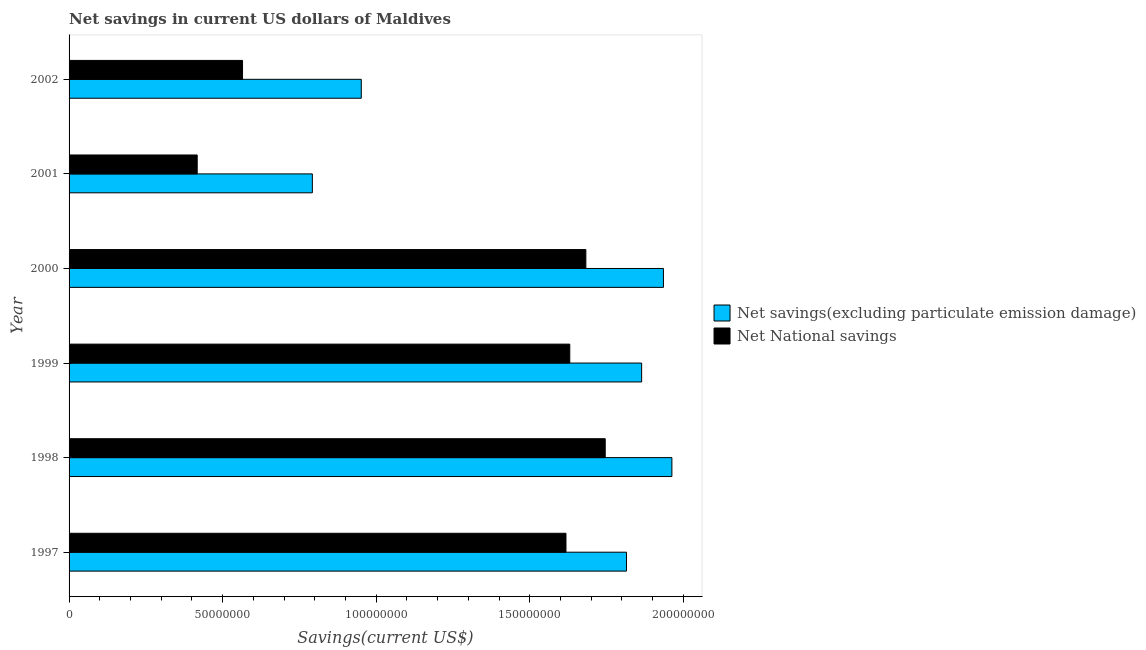Are the number of bars on each tick of the Y-axis equal?
Give a very brief answer. Yes. How many bars are there on the 2nd tick from the top?
Keep it short and to the point. 2. How many bars are there on the 6th tick from the bottom?
Make the answer very short. 2. What is the label of the 5th group of bars from the top?
Ensure brevity in your answer.  1998. In how many cases, is the number of bars for a given year not equal to the number of legend labels?
Provide a succinct answer. 0. What is the net savings(excluding particulate emission damage) in 2002?
Your response must be concise. 9.51e+07. Across all years, what is the maximum net national savings?
Offer a terse response. 1.75e+08. Across all years, what is the minimum net savings(excluding particulate emission damage)?
Your answer should be very brief. 7.92e+07. In which year was the net national savings minimum?
Give a very brief answer. 2001. What is the total net national savings in the graph?
Your answer should be very brief. 7.66e+08. What is the difference between the net national savings in 1997 and that in 1998?
Offer a very short reply. -1.28e+07. What is the difference between the net savings(excluding particulate emission damage) in 1998 and the net national savings in 2001?
Offer a terse response. 1.55e+08. What is the average net savings(excluding particulate emission damage) per year?
Keep it short and to the point. 1.55e+08. In the year 2000, what is the difference between the net savings(excluding particulate emission damage) and net national savings?
Give a very brief answer. 2.53e+07. In how many years, is the net national savings greater than 60000000 US$?
Provide a short and direct response. 4. What is the ratio of the net savings(excluding particulate emission damage) in 1997 to that in 2001?
Keep it short and to the point. 2.29. What is the difference between the highest and the second highest net savings(excluding particulate emission damage)?
Offer a very short reply. 2.75e+06. What is the difference between the highest and the lowest net savings(excluding particulate emission damage)?
Your answer should be compact. 1.17e+08. Is the sum of the net savings(excluding particulate emission damage) in 2001 and 2002 greater than the maximum net national savings across all years?
Provide a succinct answer. No. What does the 1st bar from the top in 1999 represents?
Provide a succinct answer. Net National savings. What does the 1st bar from the bottom in 2000 represents?
Your answer should be very brief. Net savings(excluding particulate emission damage). Are all the bars in the graph horizontal?
Your answer should be very brief. Yes. What is the difference between two consecutive major ticks on the X-axis?
Provide a short and direct response. 5.00e+07. Are the values on the major ticks of X-axis written in scientific E-notation?
Ensure brevity in your answer.  No. How are the legend labels stacked?
Offer a terse response. Vertical. What is the title of the graph?
Make the answer very short. Net savings in current US dollars of Maldives. Does "Borrowers" appear as one of the legend labels in the graph?
Keep it short and to the point. No. What is the label or title of the X-axis?
Make the answer very short. Savings(current US$). What is the Savings(current US$) in Net savings(excluding particulate emission damage) in 1997?
Ensure brevity in your answer.  1.81e+08. What is the Savings(current US$) in Net National savings in 1997?
Provide a succinct answer. 1.62e+08. What is the Savings(current US$) of Net savings(excluding particulate emission damage) in 1998?
Give a very brief answer. 1.96e+08. What is the Savings(current US$) in Net National savings in 1998?
Your response must be concise. 1.75e+08. What is the Savings(current US$) in Net savings(excluding particulate emission damage) in 1999?
Ensure brevity in your answer.  1.86e+08. What is the Savings(current US$) of Net National savings in 1999?
Provide a short and direct response. 1.63e+08. What is the Savings(current US$) in Net savings(excluding particulate emission damage) in 2000?
Your answer should be very brief. 1.94e+08. What is the Savings(current US$) of Net National savings in 2000?
Keep it short and to the point. 1.68e+08. What is the Savings(current US$) of Net savings(excluding particulate emission damage) in 2001?
Provide a short and direct response. 7.92e+07. What is the Savings(current US$) in Net National savings in 2001?
Give a very brief answer. 4.17e+07. What is the Savings(current US$) in Net savings(excluding particulate emission damage) in 2002?
Your response must be concise. 9.51e+07. What is the Savings(current US$) in Net National savings in 2002?
Give a very brief answer. 5.65e+07. Across all years, what is the maximum Savings(current US$) of Net savings(excluding particulate emission damage)?
Offer a very short reply. 1.96e+08. Across all years, what is the maximum Savings(current US$) of Net National savings?
Offer a very short reply. 1.75e+08. Across all years, what is the minimum Savings(current US$) of Net savings(excluding particulate emission damage)?
Your answer should be compact. 7.92e+07. Across all years, what is the minimum Savings(current US$) of Net National savings?
Offer a terse response. 4.17e+07. What is the total Savings(current US$) of Net savings(excluding particulate emission damage) in the graph?
Give a very brief answer. 9.32e+08. What is the total Savings(current US$) in Net National savings in the graph?
Keep it short and to the point. 7.66e+08. What is the difference between the Savings(current US$) of Net savings(excluding particulate emission damage) in 1997 and that in 1998?
Make the answer very short. -1.48e+07. What is the difference between the Savings(current US$) in Net National savings in 1997 and that in 1998?
Ensure brevity in your answer.  -1.28e+07. What is the difference between the Savings(current US$) in Net savings(excluding particulate emission damage) in 1997 and that in 1999?
Your answer should be very brief. -4.94e+06. What is the difference between the Savings(current US$) in Net National savings in 1997 and that in 1999?
Offer a terse response. -1.24e+06. What is the difference between the Savings(current US$) of Net savings(excluding particulate emission damage) in 1997 and that in 2000?
Offer a terse response. -1.20e+07. What is the difference between the Savings(current US$) in Net National savings in 1997 and that in 2000?
Provide a succinct answer. -6.48e+06. What is the difference between the Savings(current US$) of Net savings(excluding particulate emission damage) in 1997 and that in 2001?
Ensure brevity in your answer.  1.02e+08. What is the difference between the Savings(current US$) of Net National savings in 1997 and that in 2001?
Offer a very short reply. 1.20e+08. What is the difference between the Savings(current US$) in Net savings(excluding particulate emission damage) in 1997 and that in 2002?
Ensure brevity in your answer.  8.63e+07. What is the difference between the Savings(current US$) of Net National savings in 1997 and that in 2002?
Give a very brief answer. 1.05e+08. What is the difference between the Savings(current US$) of Net savings(excluding particulate emission damage) in 1998 and that in 1999?
Ensure brevity in your answer.  9.85e+06. What is the difference between the Savings(current US$) of Net National savings in 1998 and that in 1999?
Ensure brevity in your answer.  1.15e+07. What is the difference between the Savings(current US$) of Net savings(excluding particulate emission damage) in 1998 and that in 2000?
Give a very brief answer. 2.75e+06. What is the difference between the Savings(current US$) in Net National savings in 1998 and that in 2000?
Provide a short and direct response. 6.30e+06. What is the difference between the Savings(current US$) in Net savings(excluding particulate emission damage) in 1998 and that in 2001?
Offer a very short reply. 1.17e+08. What is the difference between the Savings(current US$) of Net National savings in 1998 and that in 2001?
Ensure brevity in your answer.  1.33e+08. What is the difference between the Savings(current US$) in Net savings(excluding particulate emission damage) in 1998 and that in 2002?
Provide a short and direct response. 1.01e+08. What is the difference between the Savings(current US$) of Net National savings in 1998 and that in 2002?
Give a very brief answer. 1.18e+08. What is the difference between the Savings(current US$) in Net savings(excluding particulate emission damage) in 1999 and that in 2000?
Make the answer very short. -7.10e+06. What is the difference between the Savings(current US$) in Net National savings in 1999 and that in 2000?
Provide a short and direct response. -5.24e+06. What is the difference between the Savings(current US$) of Net savings(excluding particulate emission damage) in 1999 and that in 2001?
Offer a very short reply. 1.07e+08. What is the difference between the Savings(current US$) of Net National savings in 1999 and that in 2001?
Your answer should be very brief. 1.21e+08. What is the difference between the Savings(current US$) in Net savings(excluding particulate emission damage) in 1999 and that in 2002?
Ensure brevity in your answer.  9.13e+07. What is the difference between the Savings(current US$) of Net National savings in 1999 and that in 2002?
Your response must be concise. 1.07e+08. What is the difference between the Savings(current US$) in Net savings(excluding particulate emission damage) in 2000 and that in 2001?
Offer a terse response. 1.14e+08. What is the difference between the Savings(current US$) of Net National savings in 2000 and that in 2001?
Make the answer very short. 1.27e+08. What is the difference between the Savings(current US$) in Net savings(excluding particulate emission damage) in 2000 and that in 2002?
Offer a terse response. 9.84e+07. What is the difference between the Savings(current US$) of Net National savings in 2000 and that in 2002?
Your answer should be compact. 1.12e+08. What is the difference between the Savings(current US$) in Net savings(excluding particulate emission damage) in 2001 and that in 2002?
Keep it short and to the point. -1.59e+07. What is the difference between the Savings(current US$) in Net National savings in 2001 and that in 2002?
Provide a short and direct response. -1.48e+07. What is the difference between the Savings(current US$) in Net savings(excluding particulate emission damage) in 1997 and the Savings(current US$) in Net National savings in 1998?
Your answer should be compact. 6.92e+06. What is the difference between the Savings(current US$) in Net savings(excluding particulate emission damage) in 1997 and the Savings(current US$) in Net National savings in 1999?
Provide a short and direct response. 1.85e+07. What is the difference between the Savings(current US$) in Net savings(excluding particulate emission damage) in 1997 and the Savings(current US$) in Net National savings in 2000?
Give a very brief answer. 1.32e+07. What is the difference between the Savings(current US$) in Net savings(excluding particulate emission damage) in 1997 and the Savings(current US$) in Net National savings in 2001?
Your response must be concise. 1.40e+08. What is the difference between the Savings(current US$) of Net savings(excluding particulate emission damage) in 1997 and the Savings(current US$) of Net National savings in 2002?
Provide a short and direct response. 1.25e+08. What is the difference between the Savings(current US$) in Net savings(excluding particulate emission damage) in 1998 and the Savings(current US$) in Net National savings in 1999?
Provide a succinct answer. 3.32e+07. What is the difference between the Savings(current US$) of Net savings(excluding particulate emission damage) in 1998 and the Savings(current US$) of Net National savings in 2000?
Your response must be concise. 2.80e+07. What is the difference between the Savings(current US$) of Net savings(excluding particulate emission damage) in 1998 and the Savings(current US$) of Net National savings in 2001?
Offer a very short reply. 1.55e+08. What is the difference between the Savings(current US$) in Net savings(excluding particulate emission damage) in 1998 and the Savings(current US$) in Net National savings in 2002?
Ensure brevity in your answer.  1.40e+08. What is the difference between the Savings(current US$) in Net savings(excluding particulate emission damage) in 1999 and the Savings(current US$) in Net National savings in 2000?
Offer a very short reply. 1.82e+07. What is the difference between the Savings(current US$) of Net savings(excluding particulate emission damage) in 1999 and the Savings(current US$) of Net National savings in 2001?
Offer a terse response. 1.45e+08. What is the difference between the Savings(current US$) of Net savings(excluding particulate emission damage) in 1999 and the Savings(current US$) of Net National savings in 2002?
Provide a short and direct response. 1.30e+08. What is the difference between the Savings(current US$) of Net savings(excluding particulate emission damage) in 2000 and the Savings(current US$) of Net National savings in 2001?
Provide a short and direct response. 1.52e+08. What is the difference between the Savings(current US$) in Net savings(excluding particulate emission damage) in 2000 and the Savings(current US$) in Net National savings in 2002?
Your answer should be compact. 1.37e+08. What is the difference between the Savings(current US$) in Net savings(excluding particulate emission damage) in 2001 and the Savings(current US$) in Net National savings in 2002?
Make the answer very short. 2.27e+07. What is the average Savings(current US$) in Net savings(excluding particulate emission damage) per year?
Offer a terse response. 1.55e+08. What is the average Savings(current US$) in Net National savings per year?
Give a very brief answer. 1.28e+08. In the year 1997, what is the difference between the Savings(current US$) in Net savings(excluding particulate emission damage) and Savings(current US$) in Net National savings?
Make the answer very short. 1.97e+07. In the year 1998, what is the difference between the Savings(current US$) in Net savings(excluding particulate emission damage) and Savings(current US$) in Net National savings?
Your answer should be very brief. 2.17e+07. In the year 1999, what is the difference between the Savings(current US$) in Net savings(excluding particulate emission damage) and Savings(current US$) in Net National savings?
Offer a very short reply. 2.34e+07. In the year 2000, what is the difference between the Savings(current US$) of Net savings(excluding particulate emission damage) and Savings(current US$) of Net National savings?
Your answer should be very brief. 2.53e+07. In the year 2001, what is the difference between the Savings(current US$) in Net savings(excluding particulate emission damage) and Savings(current US$) in Net National savings?
Provide a short and direct response. 3.75e+07. In the year 2002, what is the difference between the Savings(current US$) of Net savings(excluding particulate emission damage) and Savings(current US$) of Net National savings?
Make the answer very short. 3.87e+07. What is the ratio of the Savings(current US$) in Net savings(excluding particulate emission damage) in 1997 to that in 1998?
Your answer should be compact. 0.92. What is the ratio of the Savings(current US$) in Net National savings in 1997 to that in 1998?
Ensure brevity in your answer.  0.93. What is the ratio of the Savings(current US$) in Net savings(excluding particulate emission damage) in 1997 to that in 1999?
Offer a terse response. 0.97. What is the ratio of the Savings(current US$) of Net National savings in 1997 to that in 1999?
Offer a very short reply. 0.99. What is the ratio of the Savings(current US$) in Net savings(excluding particulate emission damage) in 1997 to that in 2000?
Ensure brevity in your answer.  0.94. What is the ratio of the Savings(current US$) of Net National savings in 1997 to that in 2000?
Make the answer very short. 0.96. What is the ratio of the Savings(current US$) in Net savings(excluding particulate emission damage) in 1997 to that in 2001?
Offer a very short reply. 2.29. What is the ratio of the Savings(current US$) of Net National savings in 1997 to that in 2001?
Offer a terse response. 3.88. What is the ratio of the Savings(current US$) of Net savings(excluding particulate emission damage) in 1997 to that in 2002?
Ensure brevity in your answer.  1.91. What is the ratio of the Savings(current US$) in Net National savings in 1997 to that in 2002?
Offer a terse response. 2.86. What is the ratio of the Savings(current US$) in Net savings(excluding particulate emission damage) in 1998 to that in 1999?
Provide a succinct answer. 1.05. What is the ratio of the Savings(current US$) in Net National savings in 1998 to that in 1999?
Ensure brevity in your answer.  1.07. What is the ratio of the Savings(current US$) in Net savings(excluding particulate emission damage) in 1998 to that in 2000?
Give a very brief answer. 1.01. What is the ratio of the Savings(current US$) of Net National savings in 1998 to that in 2000?
Ensure brevity in your answer.  1.04. What is the ratio of the Savings(current US$) of Net savings(excluding particulate emission damage) in 1998 to that in 2001?
Ensure brevity in your answer.  2.48. What is the ratio of the Savings(current US$) in Net National savings in 1998 to that in 2001?
Your response must be concise. 4.18. What is the ratio of the Savings(current US$) of Net savings(excluding particulate emission damage) in 1998 to that in 2002?
Give a very brief answer. 2.06. What is the ratio of the Savings(current US$) in Net National savings in 1998 to that in 2002?
Keep it short and to the point. 3.09. What is the ratio of the Savings(current US$) in Net savings(excluding particulate emission damage) in 1999 to that in 2000?
Your answer should be compact. 0.96. What is the ratio of the Savings(current US$) in Net National savings in 1999 to that in 2000?
Make the answer very short. 0.97. What is the ratio of the Savings(current US$) of Net savings(excluding particulate emission damage) in 1999 to that in 2001?
Make the answer very short. 2.35. What is the ratio of the Savings(current US$) in Net National savings in 1999 to that in 2001?
Your answer should be very brief. 3.91. What is the ratio of the Savings(current US$) of Net savings(excluding particulate emission damage) in 1999 to that in 2002?
Give a very brief answer. 1.96. What is the ratio of the Savings(current US$) of Net National savings in 1999 to that in 2002?
Your answer should be very brief. 2.89. What is the ratio of the Savings(current US$) of Net savings(excluding particulate emission damage) in 2000 to that in 2001?
Provide a succinct answer. 2.44. What is the ratio of the Savings(current US$) in Net National savings in 2000 to that in 2001?
Make the answer very short. 4.03. What is the ratio of the Savings(current US$) of Net savings(excluding particulate emission damage) in 2000 to that in 2002?
Your response must be concise. 2.03. What is the ratio of the Savings(current US$) of Net National savings in 2000 to that in 2002?
Offer a very short reply. 2.98. What is the ratio of the Savings(current US$) of Net savings(excluding particulate emission damage) in 2001 to that in 2002?
Keep it short and to the point. 0.83. What is the ratio of the Savings(current US$) in Net National savings in 2001 to that in 2002?
Provide a succinct answer. 0.74. What is the difference between the highest and the second highest Savings(current US$) of Net savings(excluding particulate emission damage)?
Offer a terse response. 2.75e+06. What is the difference between the highest and the second highest Savings(current US$) of Net National savings?
Give a very brief answer. 6.30e+06. What is the difference between the highest and the lowest Savings(current US$) of Net savings(excluding particulate emission damage)?
Your response must be concise. 1.17e+08. What is the difference between the highest and the lowest Savings(current US$) in Net National savings?
Provide a succinct answer. 1.33e+08. 